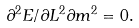<formula> <loc_0><loc_0><loc_500><loc_500>\partial ^ { 2 } E / \partial L ^ { 2 } \partial m ^ { 2 } = 0 .</formula> 